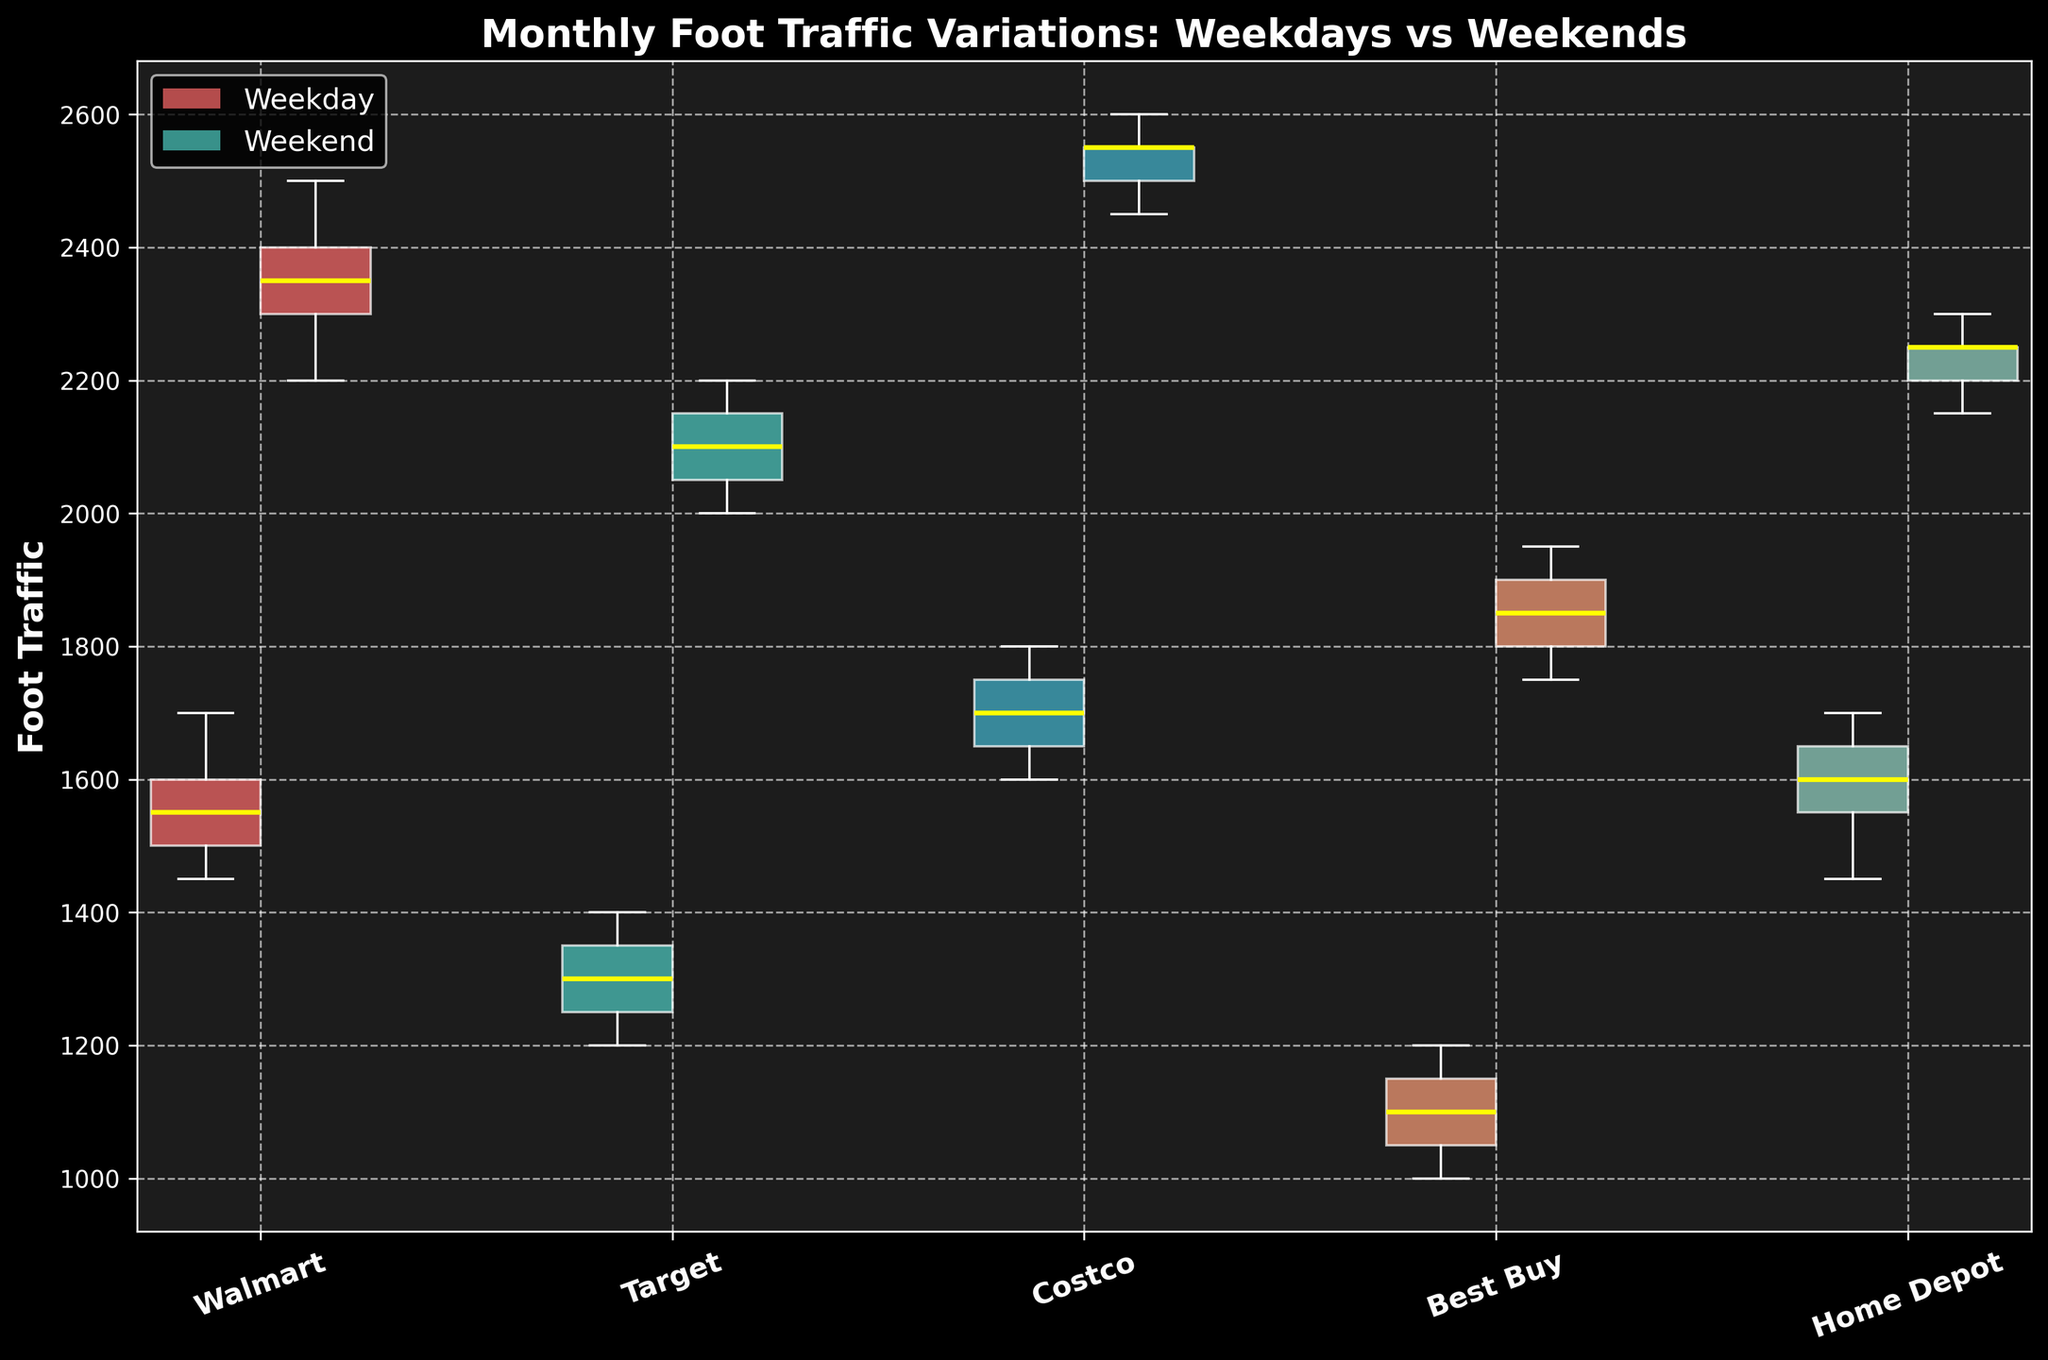What is the title of the box plot? The title of the box plot is displayed at the top of the figure, giving a summary of the data being visualized. This title is "Monthly Foot Traffic Variations: Weekdays vs Weekends".
Answer: Monthly Foot Traffic Variations: Weekdays vs Weekends Which store has the widest range of foot traffic on weekends? The width of the box plot's whiskers shows the range. For weekends, the store with the widest range is the one that stretches the most vertically. By looking at the figure, Costco's weekend whiskers span the widest.
Answer: Costco How does the median foot traffic on weekdays compare between Walmart and Target? The median is indicated by the yellow line in the box plot. Compare the height of these lines for Walmart and Target on weekdays. Walmart's median line is higher than Target's, suggesting higher median foot traffic.
Answer: Walmart has higher median foot traffic Which store has the least variation in foot traffic on weekdays? Variation is indicated by the length of the box and whiskers. The shorter the total length, the less variation. Best Buy has the shortest box and whiskers on weekdays.
Answer: Best Buy How do weekday and weekend foot traffic medians compare for Home Depot? Look for the yellow lines in the boxes for Home Depot on both weekdays and weekends. The weekend median (yellow line) is significantly higher than the weekday median.
Answer: Weekend median is higher What is the average difference in median foot traffic between weekdays and weekends for all stores? Calculate the difference in medians for each store (height of yellow lines): 
Walmart (W: 1550, WE: 2350) = 800  
Target (W: 1300, WE: 2100) = 800  
Costco (W: 1700, WE: 2550) = 850  
Best Buy (W: 1100, WE: 1850) = 750  
Home Depot (W: 1600, WE: 2250) = 650  
Sum these differences (800 + 800 + 850 + 750 + 650) = 3850, then divide by 5 for the average.
Answer: 770 Which store has the highest weekend median foot traffic? The yellow line in the weekend box indicates the median. Among all stores, Costco has the highest yellow line on weekends.
Answer: Costco Compare the maximum foot traffic on weekends among all stores. Maximum foot traffic is indicated by the upper whisker end on the weekend boxes. The figure shows that Costco’s upper whisker reaches the highest point compared to other stores.
Answer: Costco What is the range of weekday foot traffic for Walmart? The range can be calculated by looking at the upper and lower whiskers for the weekday box plot of Walmart. Subtract the lower whisker value (1450) from the upper whisker value (1700) to get the range.
Answer: 250 Which store shows the highest increase in foot traffic from weekdays to weekends? Evaluate the differences in medians (yellow lines) between weekdays and weekends for each store and identify the largest increase: 
Walmart (1550 to 2350) = 800  
Target (1300 to 2100) = 800  
Costco (1700 to 2550) = 850  
Best Buy (1100 to 1850) = 750  
Home Depot (1600 to 2250) = 650  
Costco shows the highest increase with 850.
Answer: Costco 